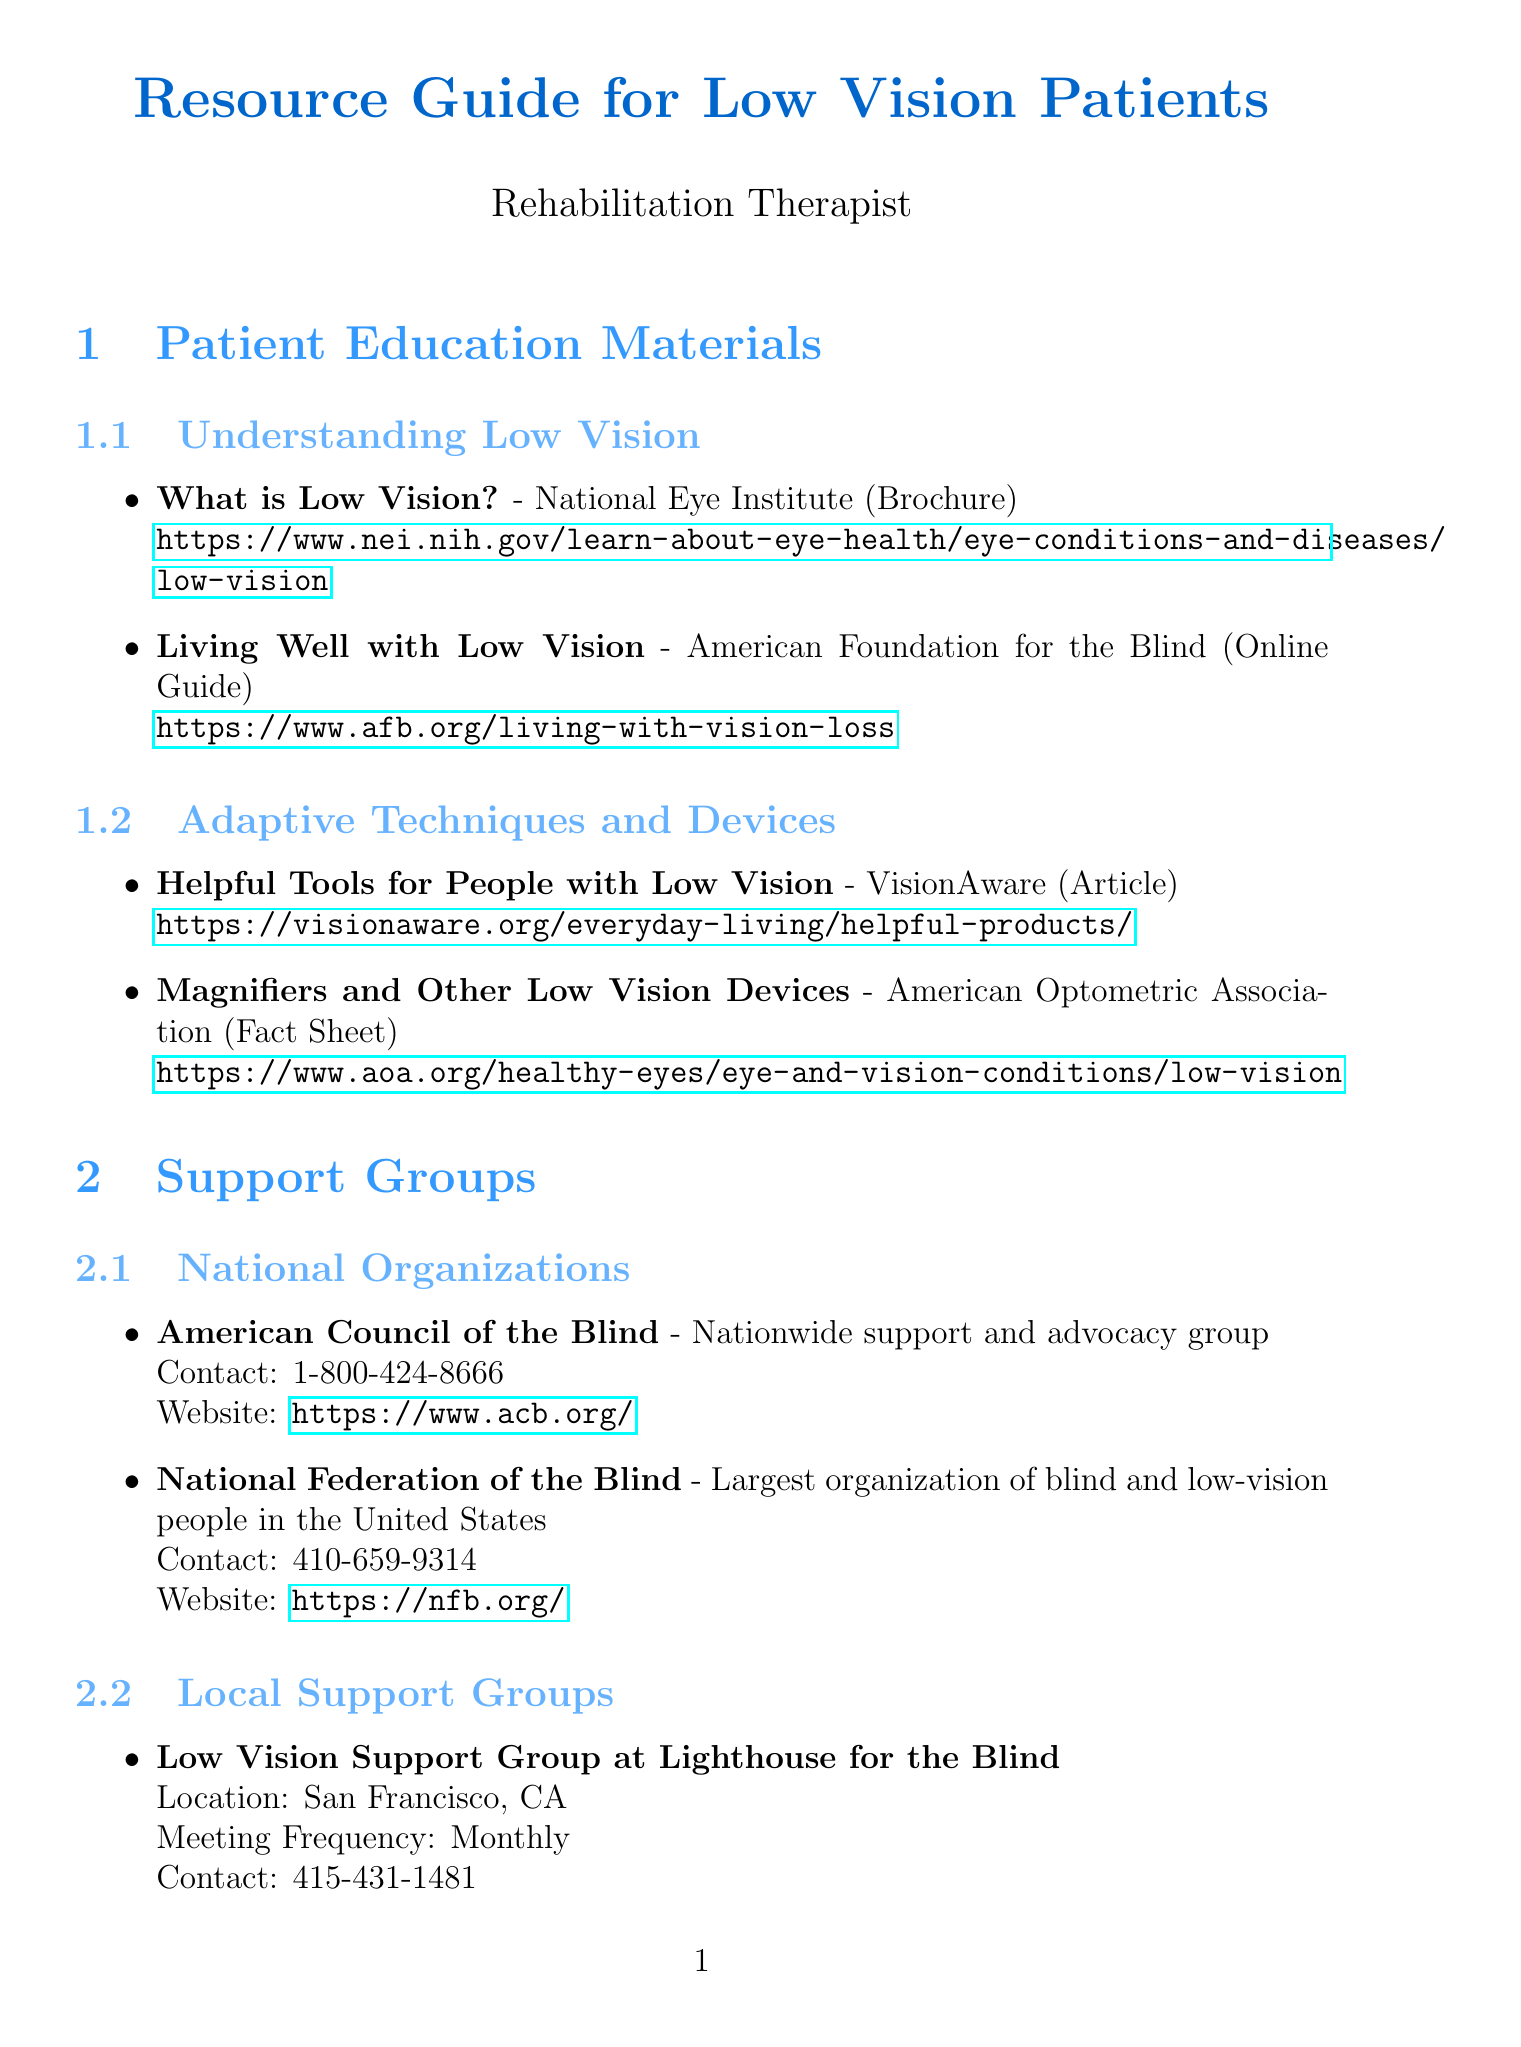What is the publisher of "What is Low Vision?" The document lists the publisher of "What is Low Vision?" as the National Eye Institute.
Answer: National Eye Institute How often does the Low Vision Support Group at Lighthouse for the Blind meet? The document specifies the meeting frequency for this group as Monthly.
Answer: Monthly What organization is the largest for blind and low-vision people in the U.S.? According to the document, the National Federation of the Blind is noted as the largest organization.
Answer: National Federation of the Blind What type of program is "Social Security Disability Insurance"? The document describes it as a Federal insurance program for workers with disabilities.
Answer: Federal insurance program How can one apply for the Supplemental Security Income program? The document states that individuals can apply at their local Social Security office or call a specified number for assistance.
Answer: Local Social Security office or 1-800-772-1213 What is the web address for the American Foundation for the Blind's guide? The document provides the URL to the guide, which is https://www.afb.org/living-with-vision-loss.
Answer: https://www.afb.org/living-with-vision-loss What is the description of "Meals on Wheels"? The document describes it as a meal delivery service for homebound individuals.
Answer: Meal delivery service for homebound individuals Which assistive technology manufacturer produces JAWS? The document identifies Freedom Scientific as the manufacturer of JAWS.
Answer: Freedom Scientific What type of devices are discussed under "Adaptive Techniques and Devices"? The document covers helpful tools and devices designed for individuals with low vision.
Answer: Tools and devices for low vision 